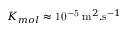<formula> <loc_0><loc_0><loc_500><loc_500>K _ { m o l } \approx 1 0 ^ { - 5 } \, m ^ { 2 } . s ^ { - 1 }</formula> 